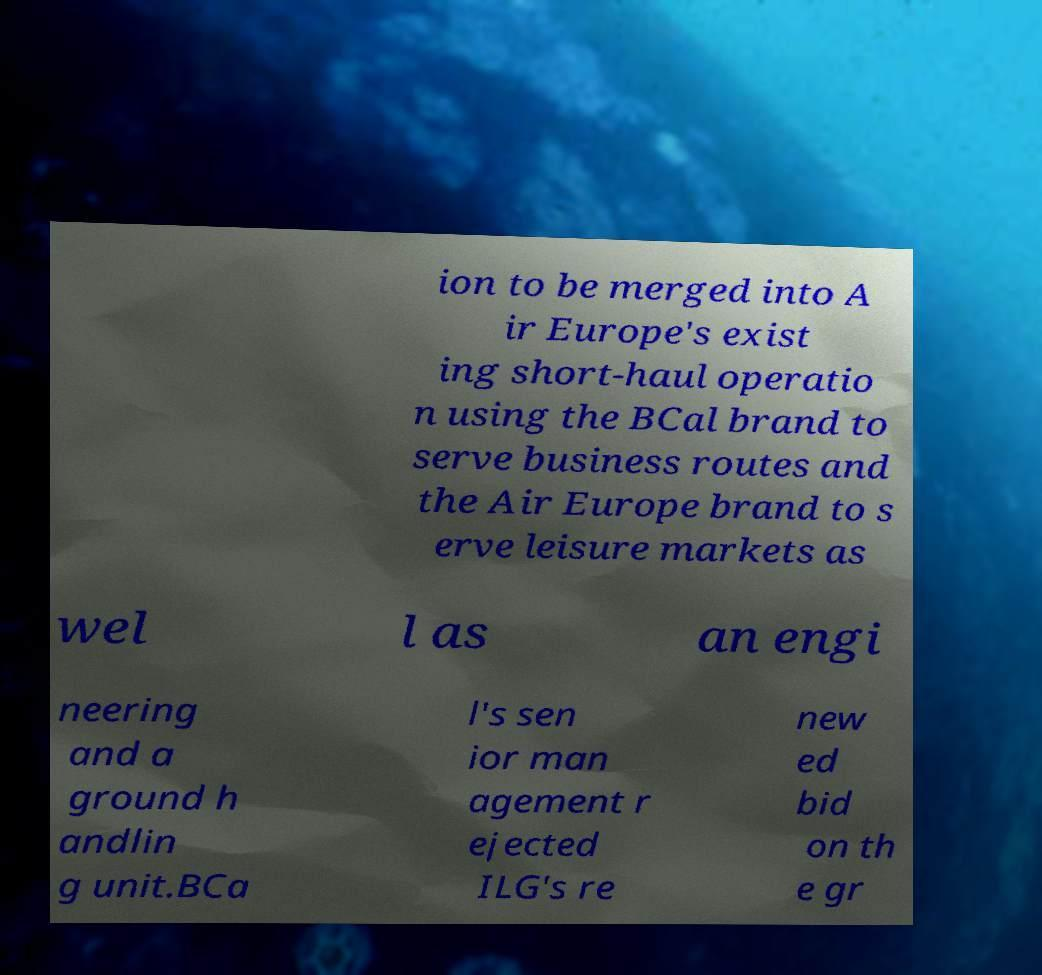Could you assist in decoding the text presented in this image and type it out clearly? ion to be merged into A ir Europe's exist ing short-haul operatio n using the BCal brand to serve business routes and the Air Europe brand to s erve leisure markets as wel l as an engi neering and a ground h andlin g unit.BCa l's sen ior man agement r ejected ILG's re new ed bid on th e gr 